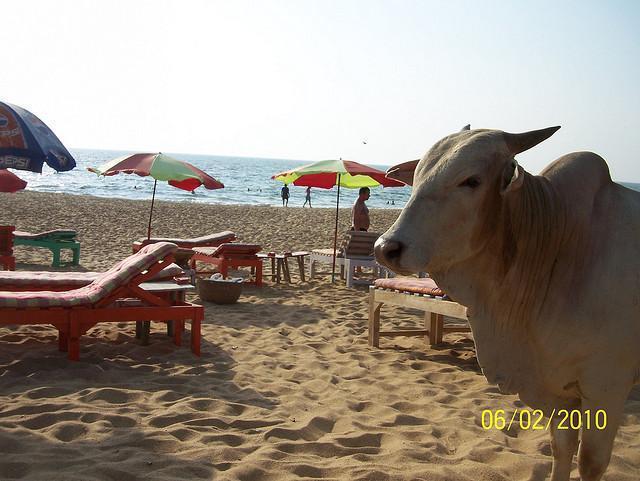How many chairs are there?
Give a very brief answer. 3. How many umbrellas can you see?
Give a very brief answer. 3. 